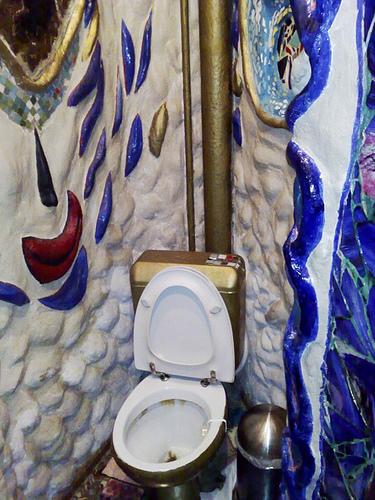Is this bathroom in someone's home or in public?
Concise answer only. Public. Is the toilet seat up or down?
Short answer required. Up. Is there a garbage can?
Short answer required. Yes. 